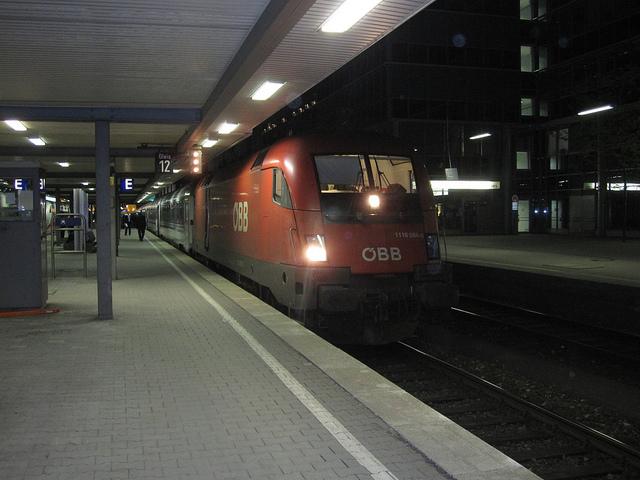What letters are on the train?
Give a very brief answer. Obb. How many lights are on?
Give a very brief answer. 1. Are the train's lights on?
Short answer required. Yes. What color is the train?
Give a very brief answer. Red. Is there a train in the station?
Concise answer only. Yes. 